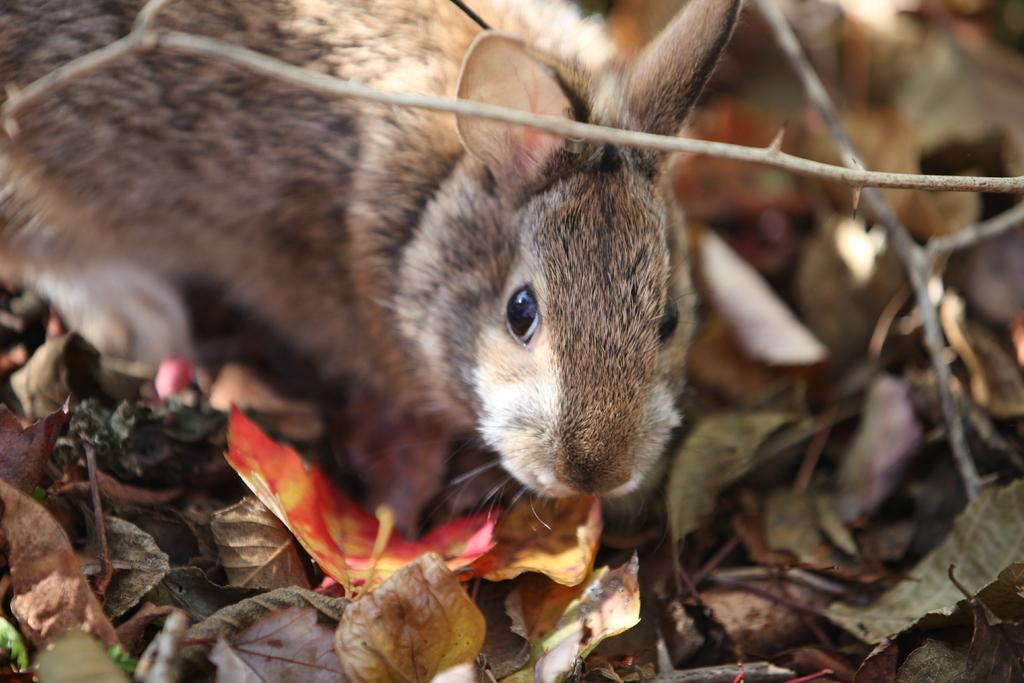Can you describe this image briefly? In this image we can see an animal. There are many dry leaves on the ground. There are few twigs on the ground in the image. 